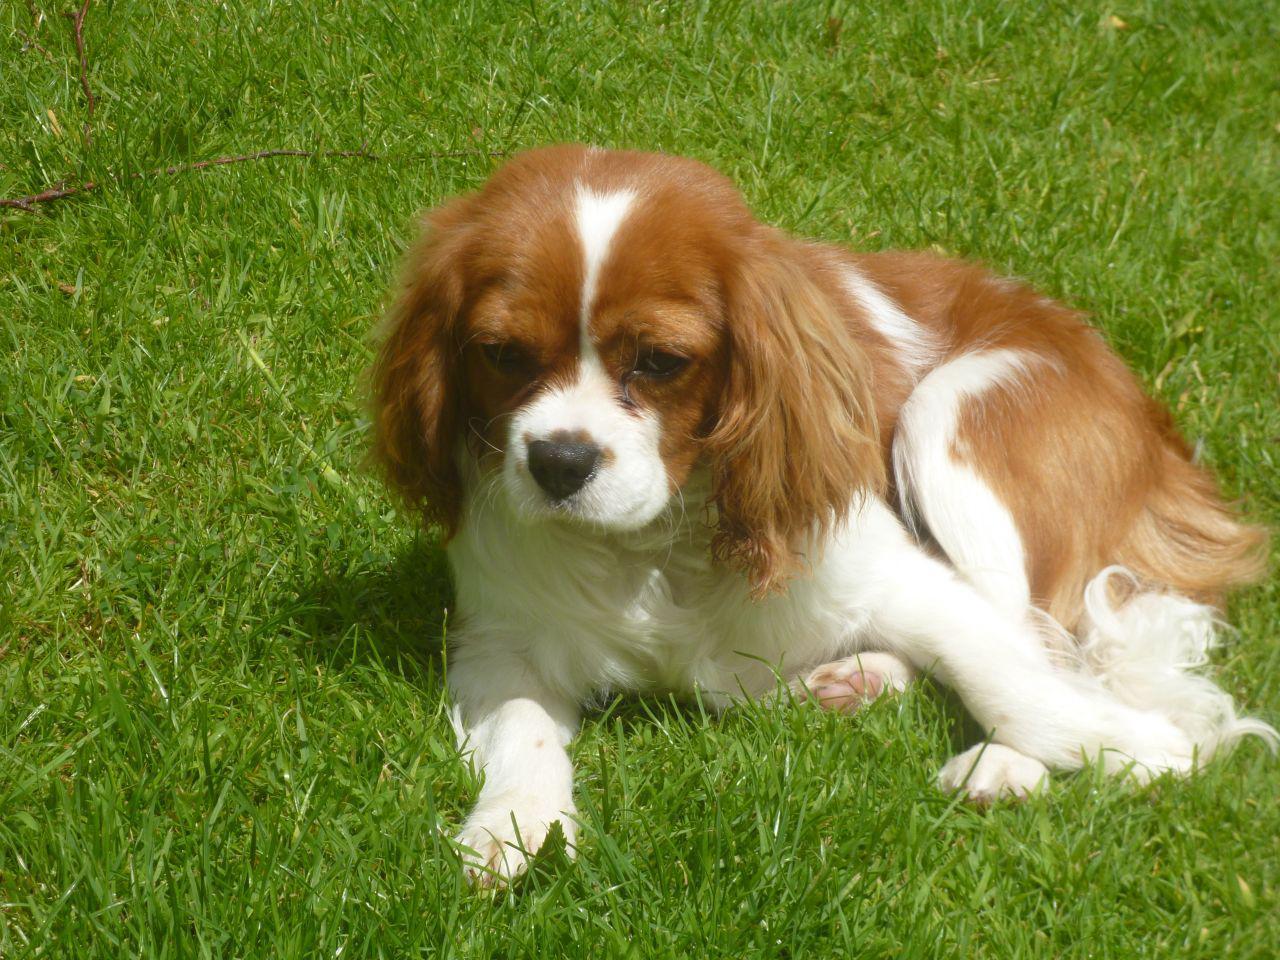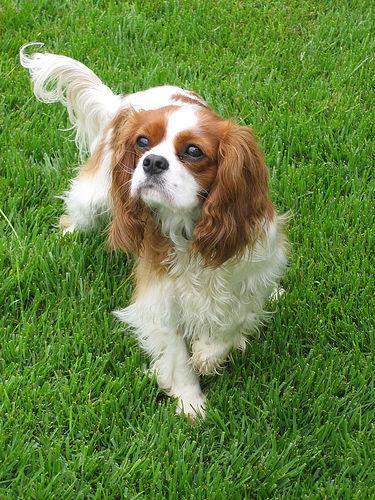The first image is the image on the left, the second image is the image on the right. Given the left and right images, does the statement "One of the images shows a dog that is standing." hold true? Answer yes or no. Yes. The first image is the image on the left, the second image is the image on the right. Considering the images on both sides, is "Right image shows a brown and white spaniel on the grass." valid? Answer yes or no. Yes. 